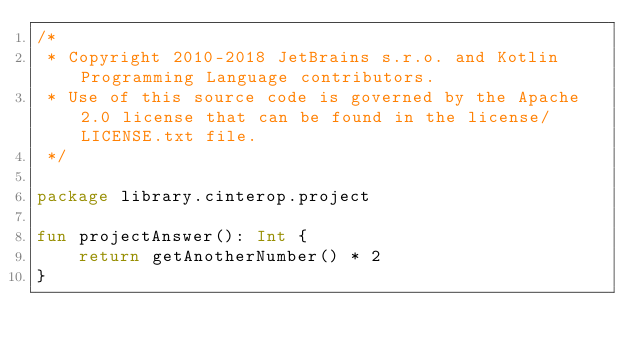<code> <loc_0><loc_0><loc_500><loc_500><_Kotlin_>/*
 * Copyright 2010-2018 JetBrains s.r.o. and Kotlin Programming Language contributors.
 * Use of this source code is governed by the Apache 2.0 license that can be found in the license/LICENSE.txt file.
 */

package library.cinterop.project

fun projectAnswer(): Int {
    return getAnotherNumber() * 2
}
</code> 